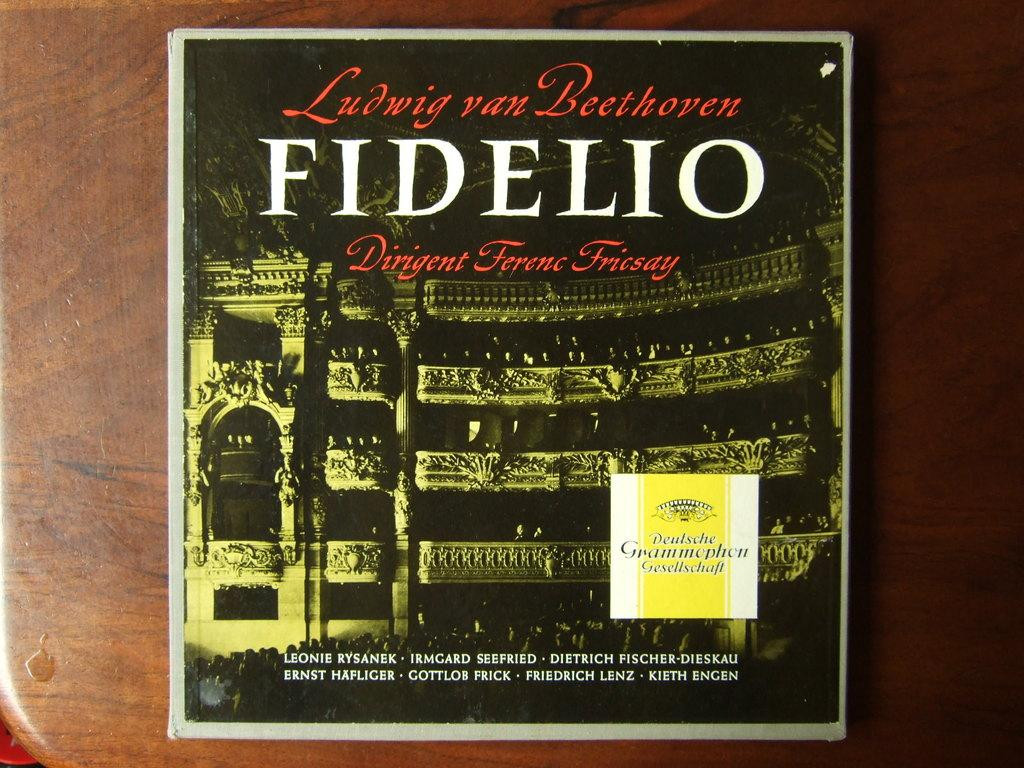<image>
Share a concise interpretation of the image provided. the word Fidelio that is on a cd 